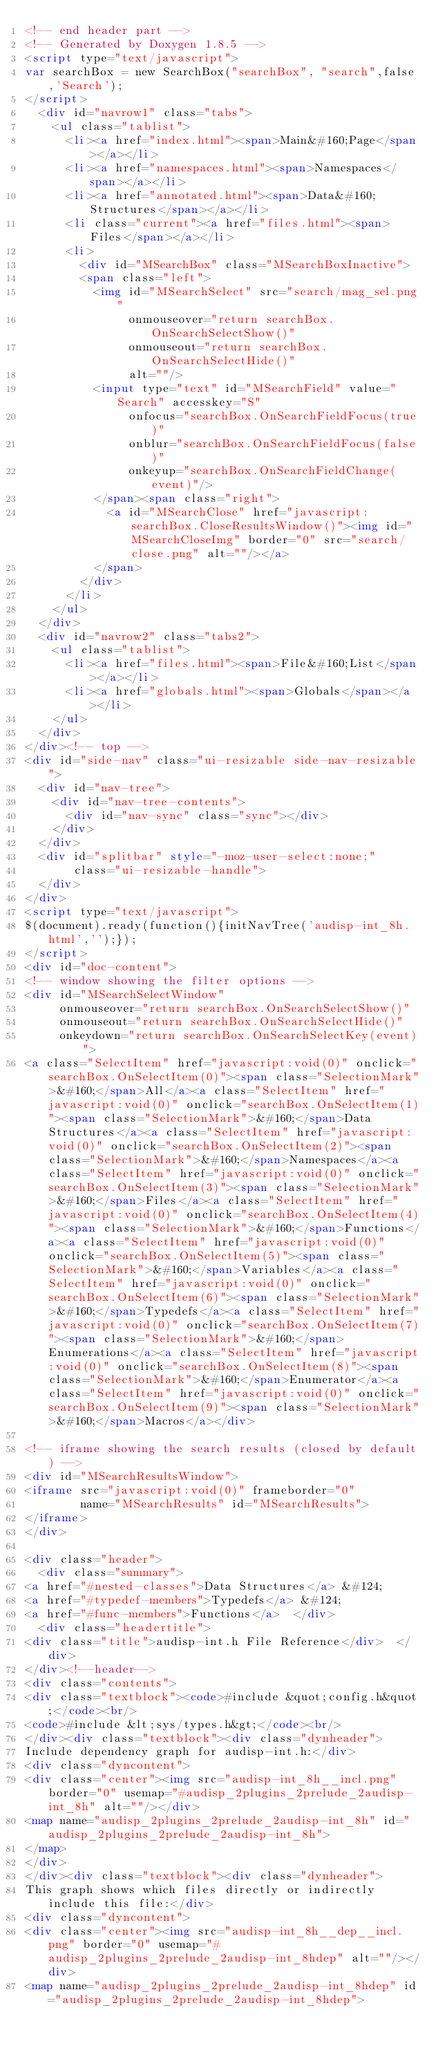Convert code to text. <code><loc_0><loc_0><loc_500><loc_500><_HTML_><!-- end header part -->
<!-- Generated by Doxygen 1.8.5 -->
<script type="text/javascript">
var searchBox = new SearchBox("searchBox", "search",false,'Search');
</script>
  <div id="navrow1" class="tabs">
    <ul class="tablist">
      <li><a href="index.html"><span>Main&#160;Page</span></a></li>
      <li><a href="namespaces.html"><span>Namespaces</span></a></li>
      <li><a href="annotated.html"><span>Data&#160;Structures</span></a></li>
      <li class="current"><a href="files.html"><span>Files</span></a></li>
      <li>
        <div id="MSearchBox" class="MSearchBoxInactive">
        <span class="left">
          <img id="MSearchSelect" src="search/mag_sel.png"
               onmouseover="return searchBox.OnSearchSelectShow()"
               onmouseout="return searchBox.OnSearchSelectHide()"
               alt=""/>
          <input type="text" id="MSearchField" value="Search" accesskey="S"
               onfocus="searchBox.OnSearchFieldFocus(true)" 
               onblur="searchBox.OnSearchFieldFocus(false)" 
               onkeyup="searchBox.OnSearchFieldChange(event)"/>
          </span><span class="right">
            <a id="MSearchClose" href="javascript:searchBox.CloseResultsWindow()"><img id="MSearchCloseImg" border="0" src="search/close.png" alt=""/></a>
          </span>
        </div>
      </li>
    </ul>
  </div>
  <div id="navrow2" class="tabs2">
    <ul class="tablist">
      <li><a href="files.html"><span>File&#160;List</span></a></li>
      <li><a href="globals.html"><span>Globals</span></a></li>
    </ul>
  </div>
</div><!-- top -->
<div id="side-nav" class="ui-resizable side-nav-resizable">
  <div id="nav-tree">
    <div id="nav-tree-contents">
      <div id="nav-sync" class="sync"></div>
    </div>
  </div>
  <div id="splitbar" style="-moz-user-select:none;" 
       class="ui-resizable-handle">
  </div>
</div>
<script type="text/javascript">
$(document).ready(function(){initNavTree('audisp-int_8h.html','');});
</script>
<div id="doc-content">
<!-- window showing the filter options -->
<div id="MSearchSelectWindow"
     onmouseover="return searchBox.OnSearchSelectShow()"
     onmouseout="return searchBox.OnSearchSelectHide()"
     onkeydown="return searchBox.OnSearchSelectKey(event)">
<a class="SelectItem" href="javascript:void(0)" onclick="searchBox.OnSelectItem(0)"><span class="SelectionMark">&#160;</span>All</a><a class="SelectItem" href="javascript:void(0)" onclick="searchBox.OnSelectItem(1)"><span class="SelectionMark">&#160;</span>Data Structures</a><a class="SelectItem" href="javascript:void(0)" onclick="searchBox.OnSelectItem(2)"><span class="SelectionMark">&#160;</span>Namespaces</a><a class="SelectItem" href="javascript:void(0)" onclick="searchBox.OnSelectItem(3)"><span class="SelectionMark">&#160;</span>Files</a><a class="SelectItem" href="javascript:void(0)" onclick="searchBox.OnSelectItem(4)"><span class="SelectionMark">&#160;</span>Functions</a><a class="SelectItem" href="javascript:void(0)" onclick="searchBox.OnSelectItem(5)"><span class="SelectionMark">&#160;</span>Variables</a><a class="SelectItem" href="javascript:void(0)" onclick="searchBox.OnSelectItem(6)"><span class="SelectionMark">&#160;</span>Typedefs</a><a class="SelectItem" href="javascript:void(0)" onclick="searchBox.OnSelectItem(7)"><span class="SelectionMark">&#160;</span>Enumerations</a><a class="SelectItem" href="javascript:void(0)" onclick="searchBox.OnSelectItem(8)"><span class="SelectionMark">&#160;</span>Enumerator</a><a class="SelectItem" href="javascript:void(0)" onclick="searchBox.OnSelectItem(9)"><span class="SelectionMark">&#160;</span>Macros</a></div>

<!-- iframe showing the search results (closed by default) -->
<div id="MSearchResultsWindow">
<iframe src="javascript:void(0)" frameborder="0" 
        name="MSearchResults" id="MSearchResults">
</iframe>
</div>

<div class="header">
  <div class="summary">
<a href="#nested-classes">Data Structures</a> &#124;
<a href="#typedef-members">Typedefs</a> &#124;
<a href="#func-members">Functions</a>  </div>
  <div class="headertitle">
<div class="title">audisp-int.h File Reference</div>  </div>
</div><!--header-->
<div class="contents">
<div class="textblock"><code>#include &quot;config.h&quot;</code><br/>
<code>#include &lt;sys/types.h&gt;</code><br/>
</div><div class="textblock"><div class="dynheader">
Include dependency graph for audisp-int.h:</div>
<div class="dyncontent">
<div class="center"><img src="audisp-int_8h__incl.png" border="0" usemap="#audisp_2plugins_2prelude_2audisp-int_8h" alt=""/></div>
<map name="audisp_2plugins_2prelude_2audisp-int_8h" id="audisp_2plugins_2prelude_2audisp-int_8h">
</map>
</div>
</div><div class="textblock"><div class="dynheader">
This graph shows which files directly or indirectly include this file:</div>
<div class="dyncontent">
<div class="center"><img src="audisp-int_8h__dep__incl.png" border="0" usemap="#audisp_2plugins_2prelude_2audisp-int_8hdep" alt=""/></div>
<map name="audisp_2plugins_2prelude_2audisp-int_8hdep" id="audisp_2plugins_2prelude_2audisp-int_8hdep"></code> 